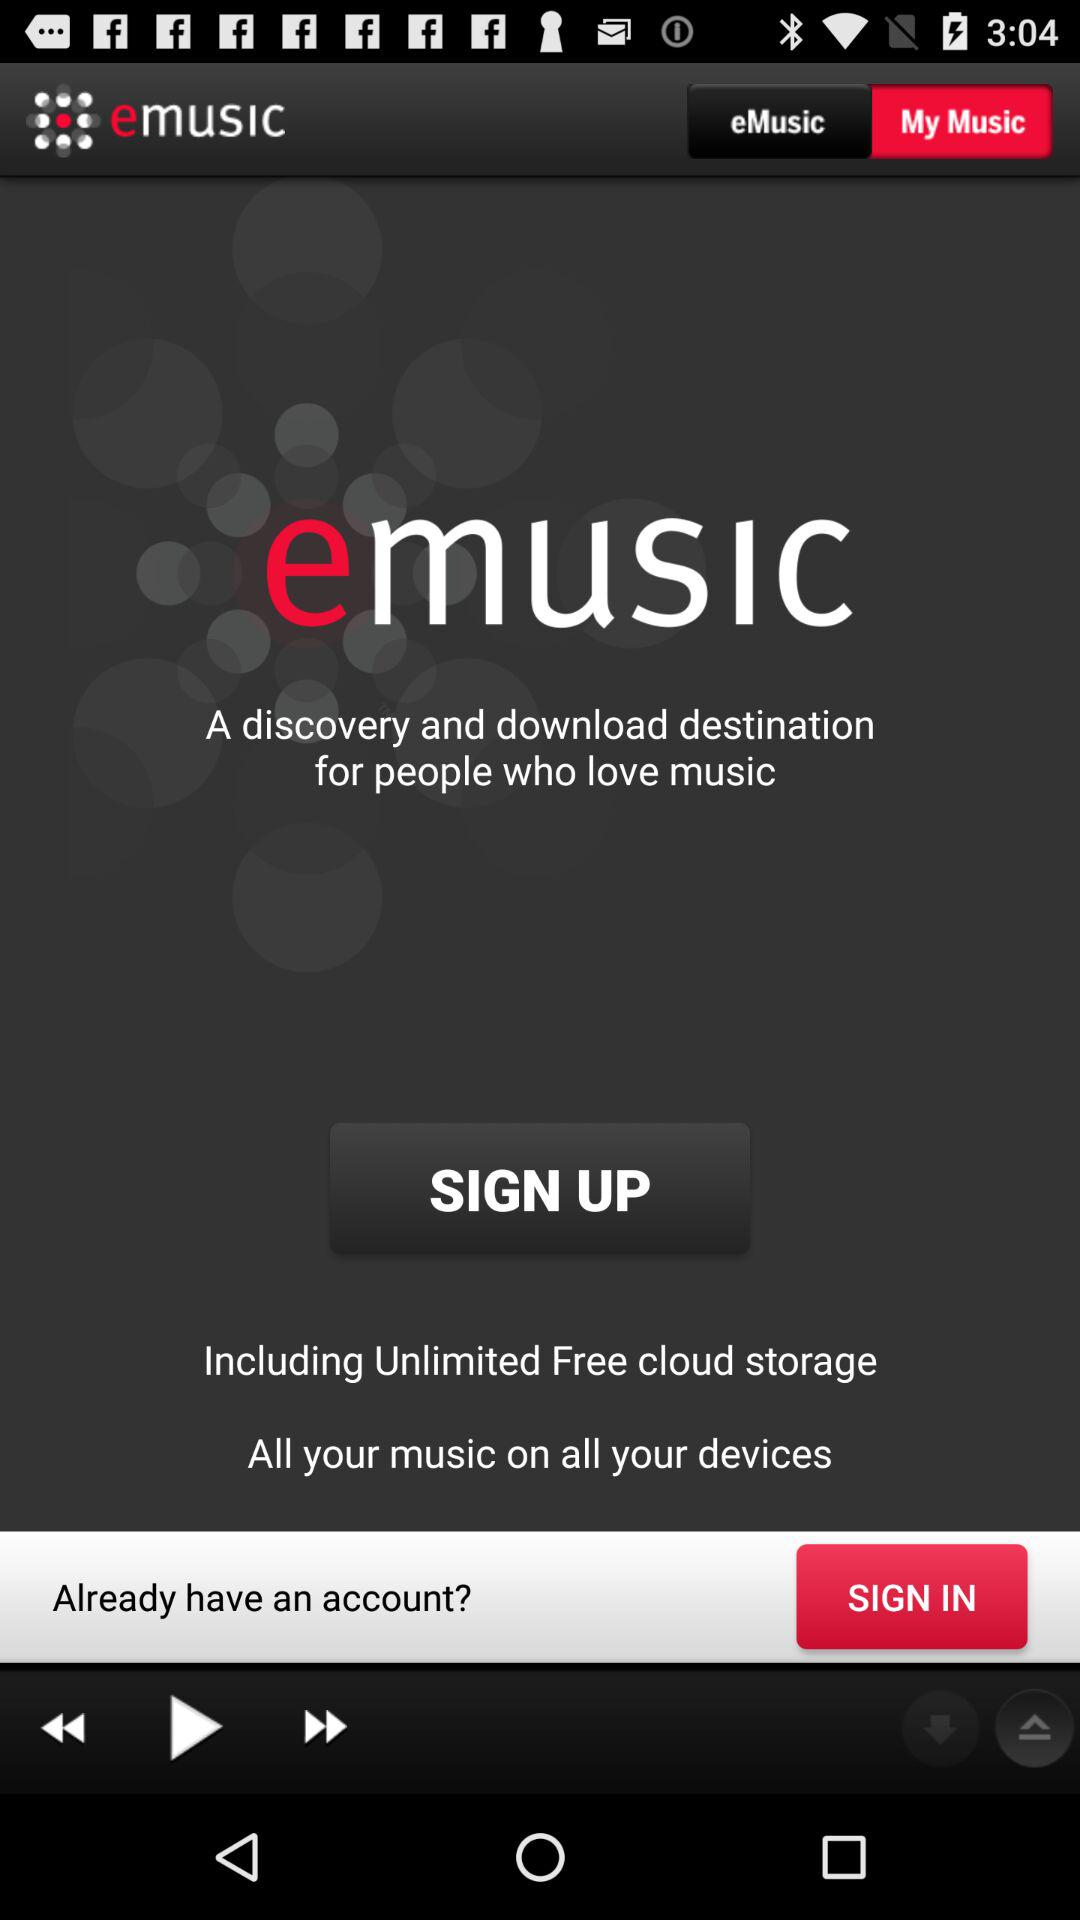What is the name of the application? The name of the application is "emusic". 